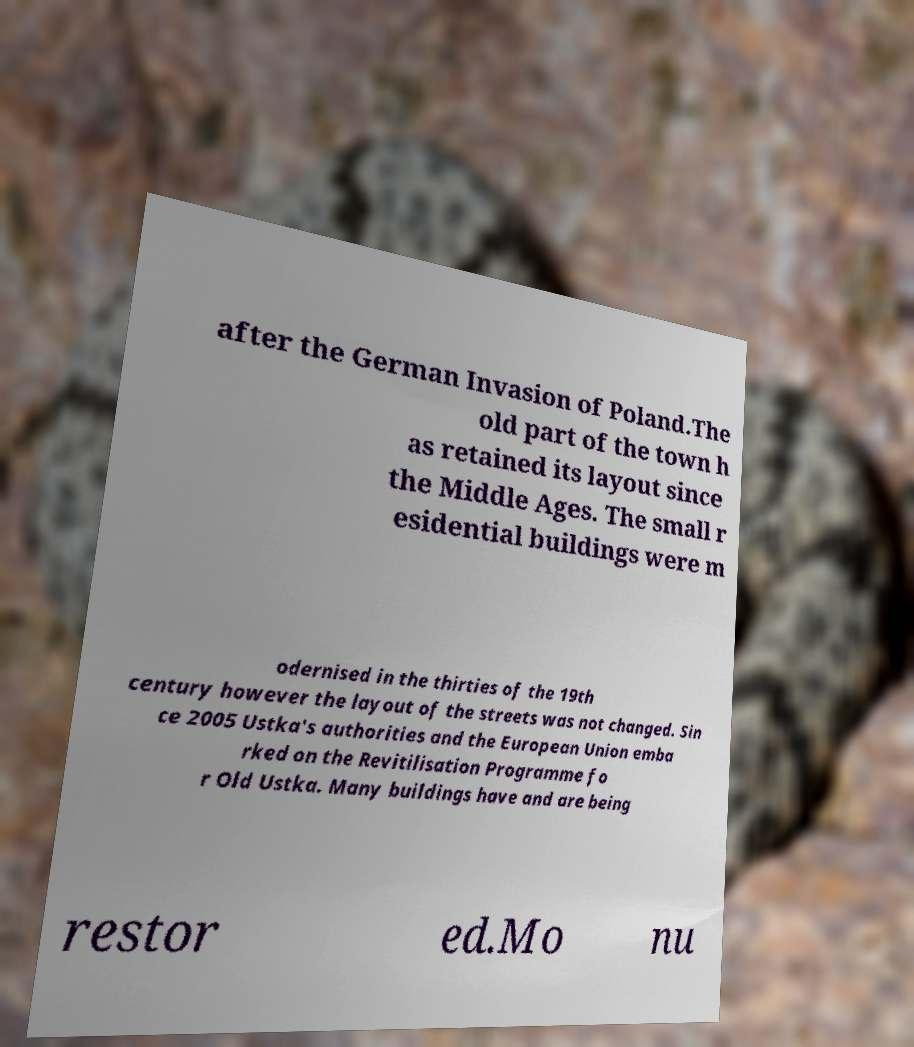What messages or text are displayed in this image? I need them in a readable, typed format. after the German Invasion of Poland.The old part of the town h as retained its layout since the Middle Ages. The small r esidential buildings were m odernised in the thirties of the 19th century however the layout of the streets was not changed. Sin ce 2005 Ustka's authorities and the European Union emba rked on the Revitilisation Programme fo r Old Ustka. Many buildings have and are being restor ed.Mo nu 